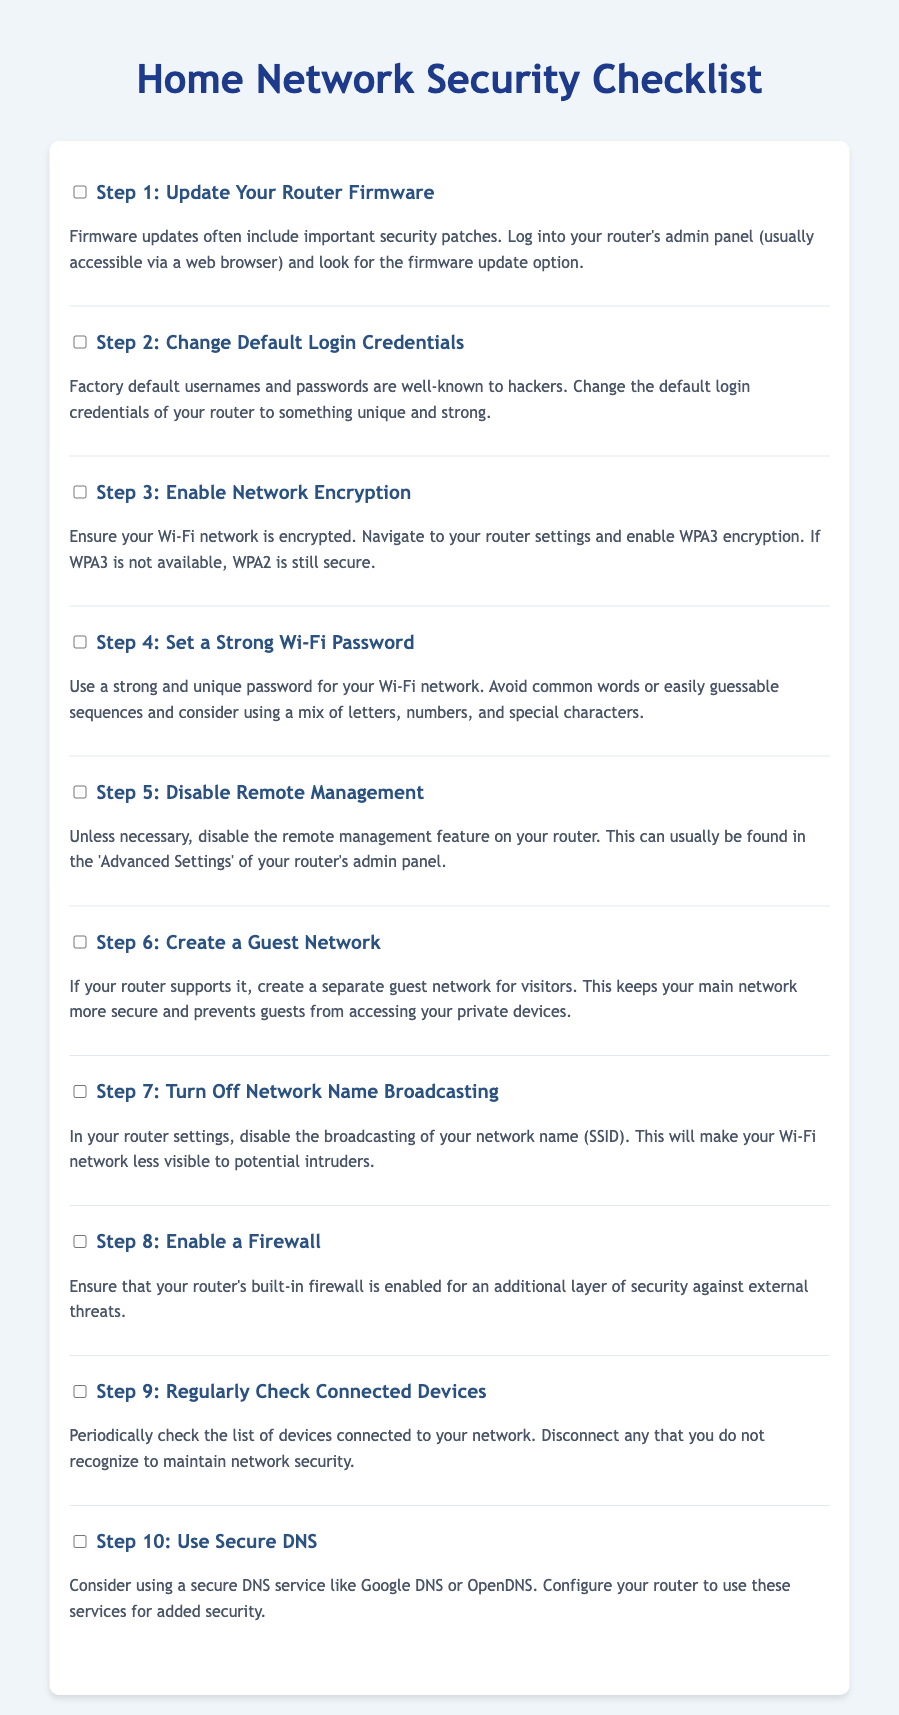What is the first step in the checklist? The first step in the checklist is to update your router firmware as mentioned in Step 1.
Answer: Update Your Router Firmware What should you avoid when setting a Wi-Fi password? The checklist advises against using common words or easily guessable sequences for your Wi-Fi password.
Answer: Common words What is recommended to enable for additional security? The checklist suggests enabling a firewall for an additional layer of security against external threats.
Answer: A firewall How many steps are included in the checklist? The checklist consists of a total of ten steps for strengthening home network security.
Answer: Ten What type of network can you create for visitors? The document mentions creating a guest network for visitors as a safety measure.
Answer: Guest Network What type of encryption should you enable on your Wi-Fi network? The checklist recommends enabling WPA3 encryption for your Wi-Fi network, or WPA2 if WPA3 is unavailable.
Answer: WPA3 What feature should be disabled to make your network less visible? Step 7 advises disabling network name broadcasting to make the Wi-Fi network less visible.
Answer: Broadcasting What is suggested for periodically maintaining network security? The checklist suggests regularly checking connected devices to maintain network security.
Answer: Check connected devices Which DNS service is recommended? The document recommends using secure DNS services like Google DNS or OpenDNS for added security.
Answer: Google DNS or OpenDNS 